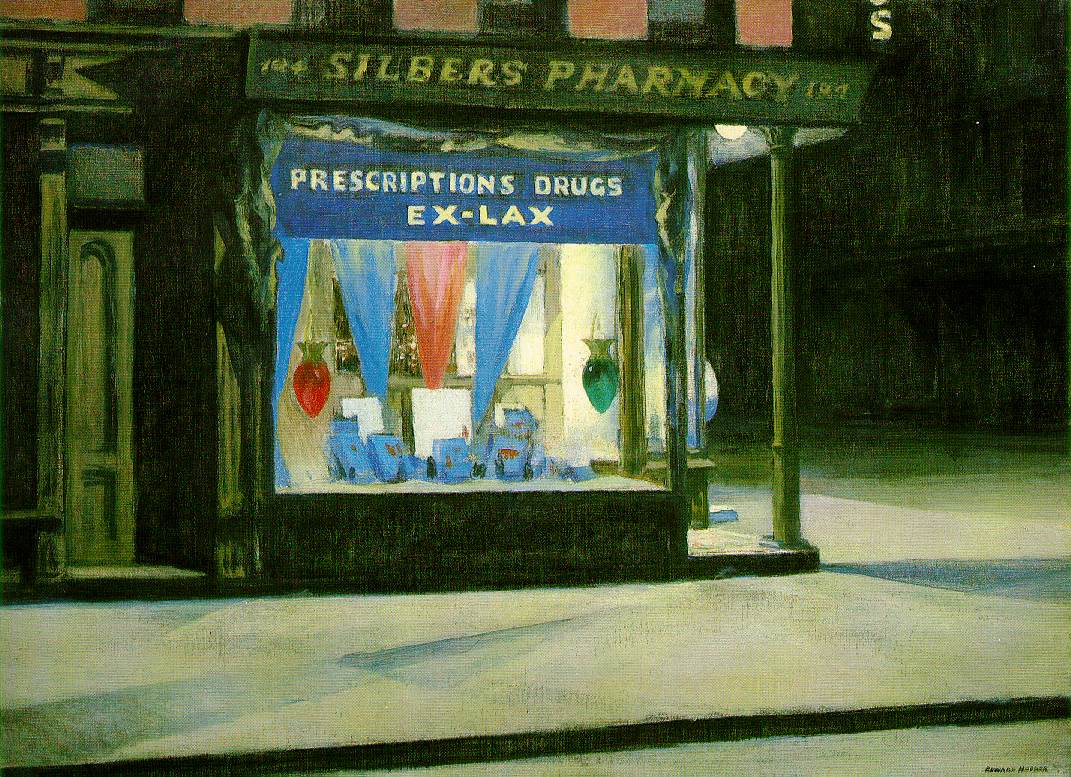Can you discuss the significance of the items displayed in the pharmacy's window? The items in the window of Silber’s Pharmacy, prominently featuring bottles and colorful decorations, serve both a practical and symbolic role. Practically, they advertise the products available to customers, highlighting over-the-counter medications like Ex-Lax, which hint at the common health concerns of the era. Symbolically, these items reflect the role of the pharmacy as a beacon of health, safety, and wellness in the community, a place where one might find relief. The vibrant display amidst the dark urban setting also suggests a beacon-like presence in the neighborhood, drawing in those in need during quieter, perhaps more vulnerable hours. 